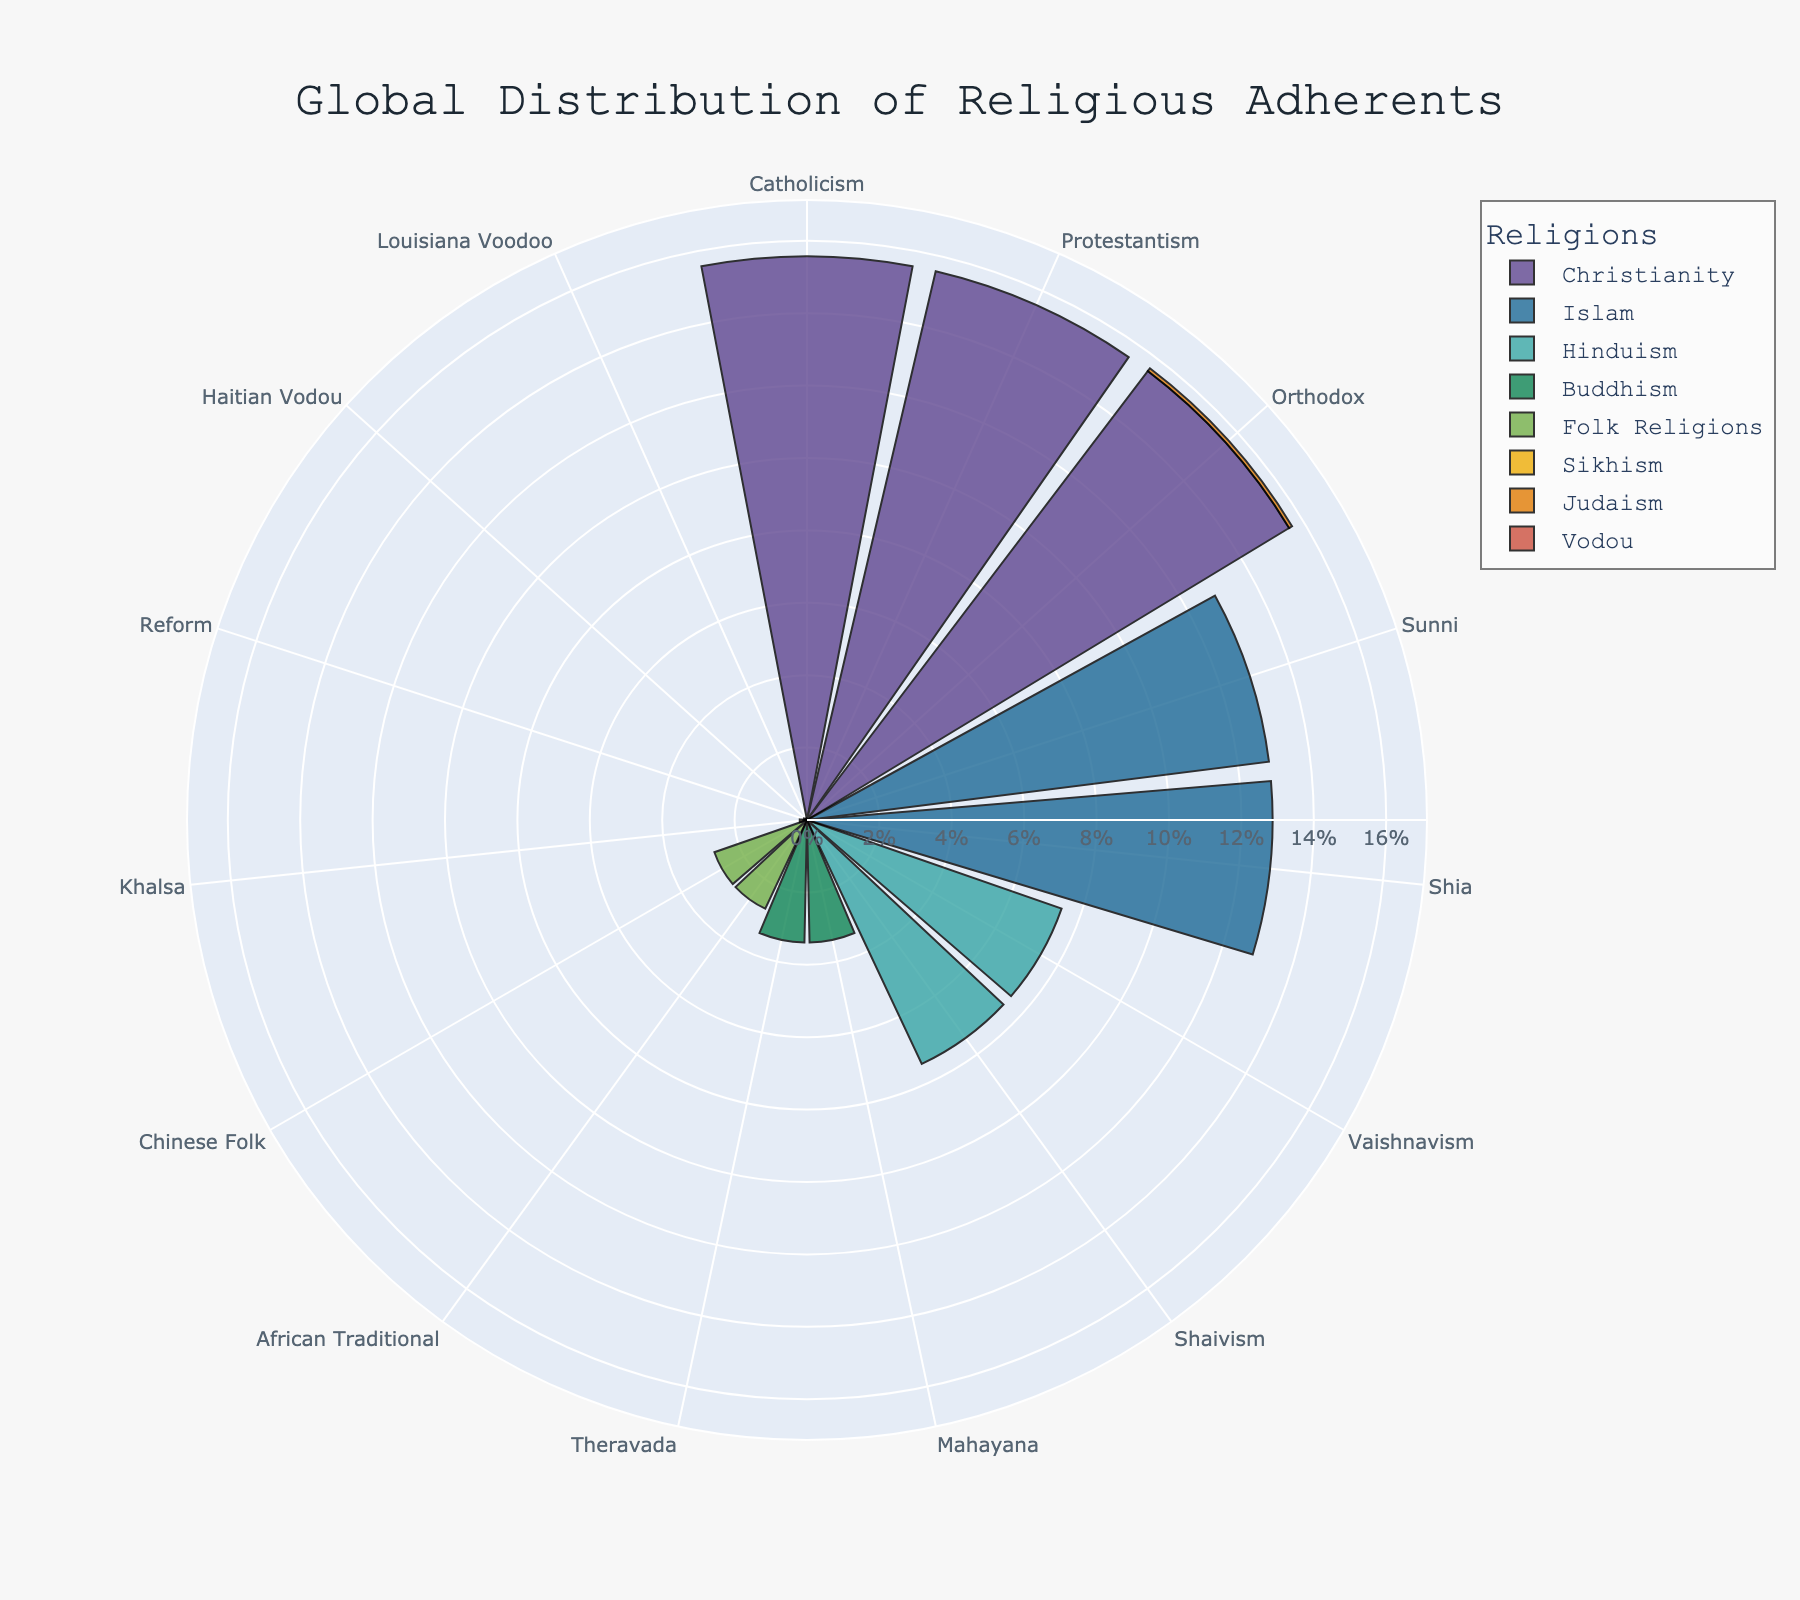What is the title of the figure? The title is displayed prominently at the top of the figure. It helps to understand what the visualization is about. The title is "Global Distribution of Religious Adherents".
Answer: Global Distribution of Religious Adherents Which religion has the highest percentage of adherents? By observing the lengths of the bars, the longest ones represent Christianity. Therefore, Christianity has the highest percentage of adherents.
Answer: Christianity How many subgroups are represented for Islam? Look at the figures' segments for Islam. Count the different subgroups labeled under Islam. There are two subgroups: Sunni and Shia.
Answer: 2 What is the percentage of adherents for Vaishnavism within Hinduism? Locate the segments for Hinduism and find the Vaishnavism portion. The percentage is equal to the segment length relative to the total chart.
Answer: 55% Which has a higher percentage, Chinese Folk in Folk Religions or Khalsa in Sikhism? Compare the bars for Chinese Folk under Folk Religions and Khalsa under Sikhism. The Chinese Folk segment is longer.
Answer: Chinese Folk What is the combined percentage of adherents for all Vodou traditions? Add the percentages for Haitian Vodou and Louisiana Voodoo from their visual segments. The total will be the sum of the individual percentages.
Answer: 0.16% How does the percentage of Mahayana Buddhism compare to Orthodox Judaism? Compare the segment lengths of Mahayana Buddhism and Orthodox Judaism. Mahayana Buddhism has substantially more followers, indicating a higher percentage compared to Orthodox Judaism.
Answer: Mahayana Buddhism has a higher percentage What is the difference in the percentage of adherents between Catholicism and Sunni Islam? Refer to the segments for Catholicism under Christianity and Sunni under Islam. Subtract the shorter segment of Sunni from the longer segment of Catholicism to find the difference.
Answer: 0% What color is used for Christianity in the figure? The bars for Christianity will have a unique color. Identify the color in the legend and the corresponding segments. This helps to distinguish between different religions visually.
Answer: Check the visualization Which subgroup of Buddhism has a larger percentage, Mahayana or Theravada? Compare the segment lengths for Mahayana and Theravada within Buddhism. The longer segment represents the larger percentage.
Answer: They are equal 